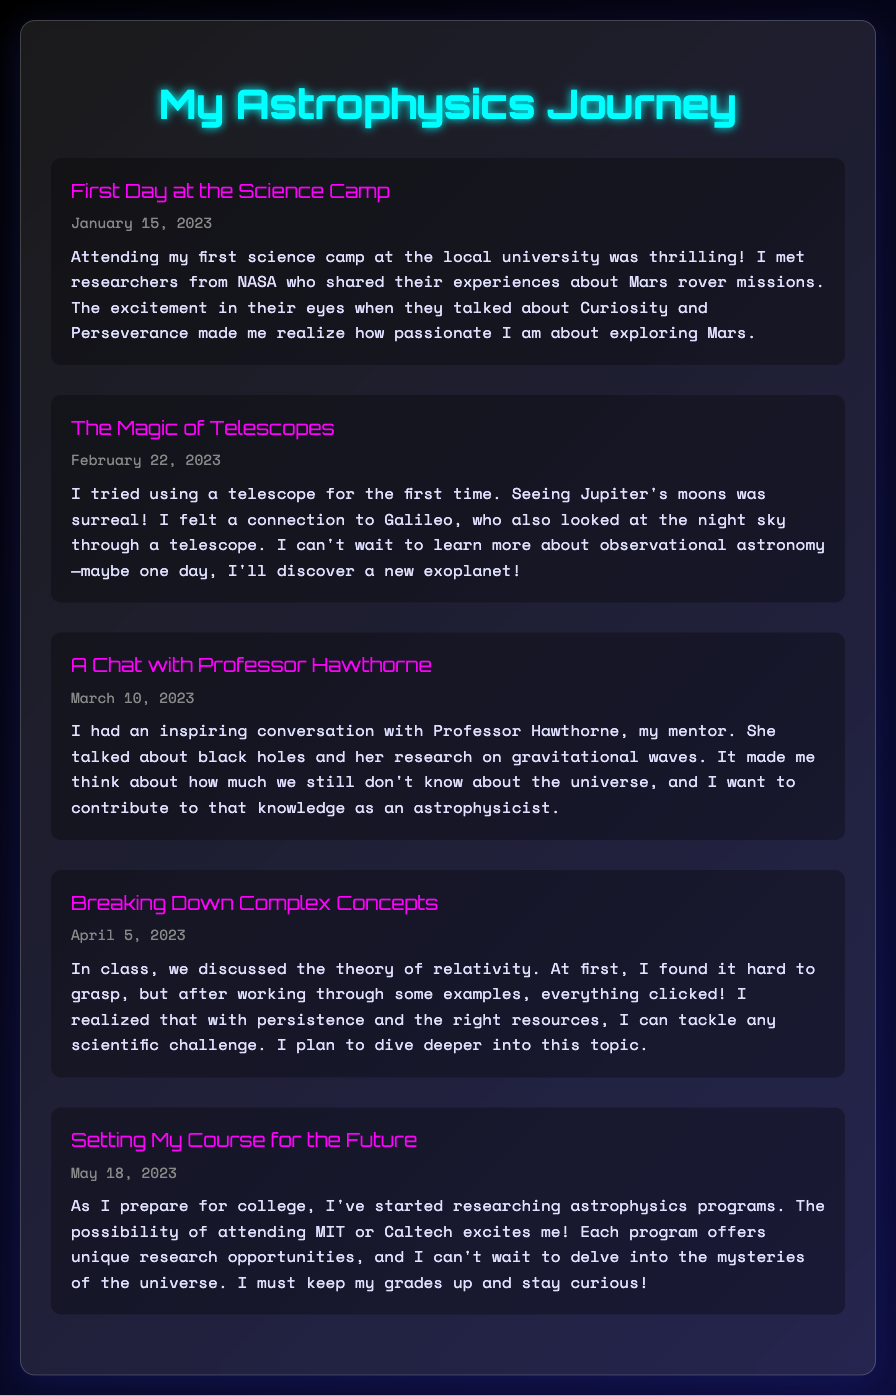What is the title of the first journal entry? The title of the first journal entry is located at the top of the entry section within the document.
Answer: First Day at the Science Camp Who is mentioned as a mentor in the journal? The name of the mentor is explicitly stated in one of the entries, emphasizing the significance of their role in the author's journey.
Answer: Professor Hawthorne What celestial body did the author see through a telescope? The specific celestial body observed is mentioned in the context of the author's first telescope experience.
Answer: Jupiter When did the author discuss the theory of relativity? The exact date of the entry where the theory of relativity was discussed is provided clearly.
Answer: April 5, 2023 Which universities is the author considering for their astrophysics education? The universities are listed in the final entry, outlining the author's future aspirations.
Answer: MIT or Caltech What was the author's feeling about meeting NASA researchers? The emotional response to meeting the NASA researchers is conveyed in the first journal entry, highlighting the impact on the author.
Answer: Thrilling What breakthrough did the author experience while learning complex concepts? The document describes a specific moment of understanding, demonstrating the author's resilience and growth.
Answer: Everything clicked What epiphany did the author experience about scientific challenges? The reflection mentions a realization that connects persistence with overcoming challenges in science.
Answer: Persistence and the right resources 